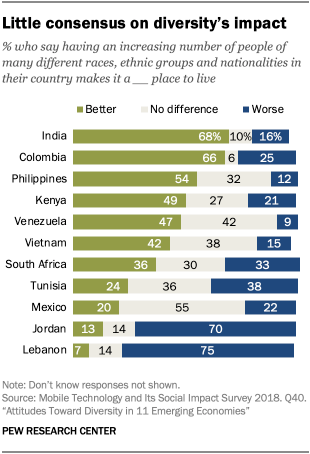Give some essential details in this illustration. The sum of the lowest value of the green and blue bars is less than the largest value of the gray bar. According to a recent survey, 0.68% of Indians believe that things are getting better. 